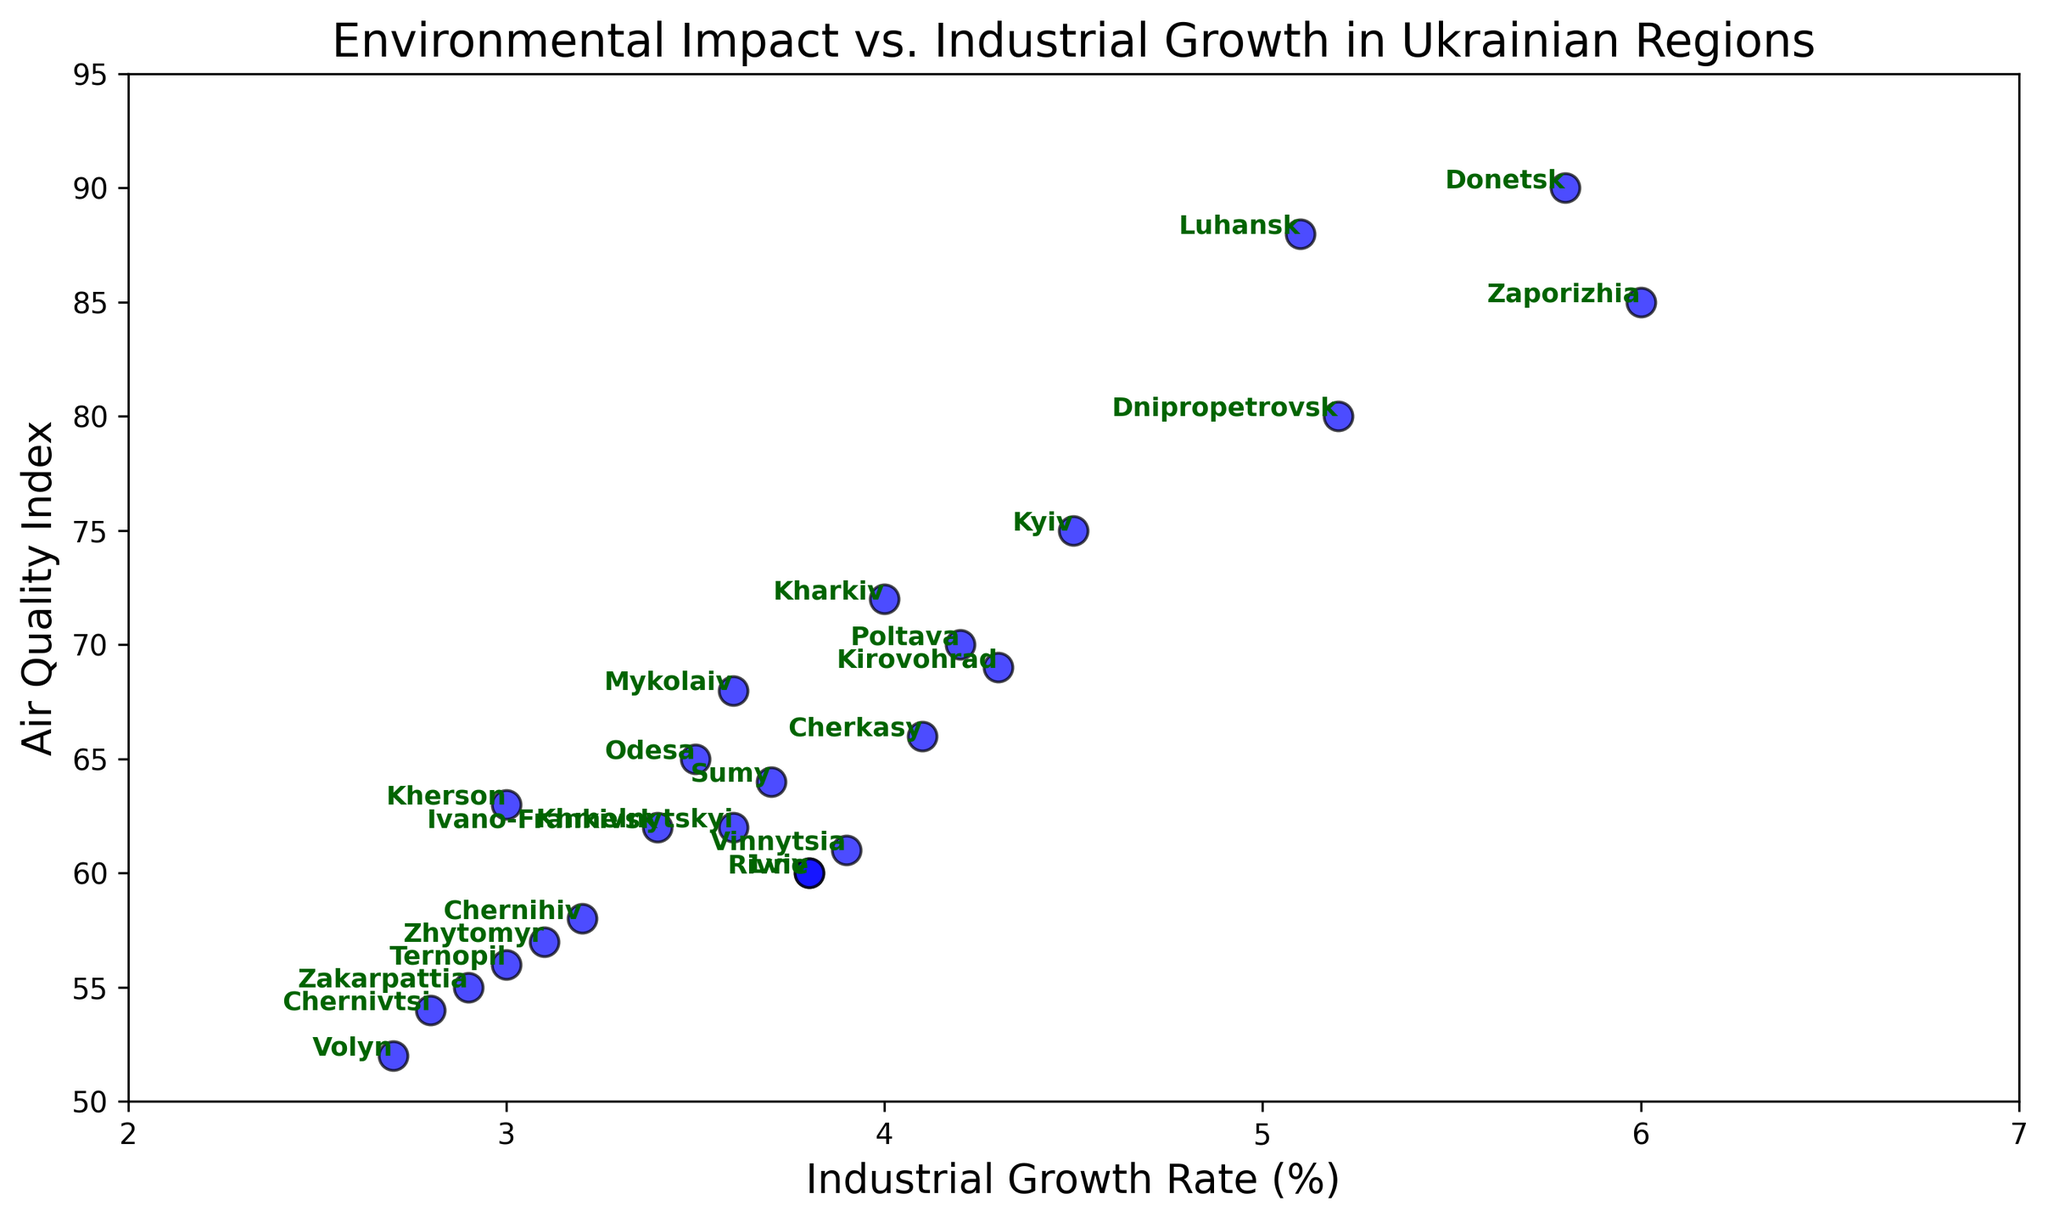Which region has the highest industrial growth rate? By observing the scatter plot, locate the point on the x-axis representing the highest value of 'Industrial Growth Rate'. Check the annotation to find the corresponding region.
Answer: Zaporizhia What is the air quality index for Lviv? Locate the point labeled 'Lviv' on the scatter plot, then read the corresponding value on the y-axis, which represents the 'Air Quality Index'.
Answer: 60 Which regions have a higher air quality index than Kharkiv? First, identify the air quality index value for Kharkiv, which is 72. Look for all other regions on the scatter plot with air quality index values greater than 72 by checking the y-axis.
Answer: Dnipropetrovsk, Zaporizhia, Donetsk, Luhansk Is there a region with a higher industrial growth rate than Kyiv but lower air quality? Locate Kyiv's point on the scatter plot, then identify regions with a higher 'Industrial Growth Rate' (greater than 4.5%) and compare their 'Air Quality Index' values to see if they are lower than 75.
Answer: Dnipropetrovsk, Zaporizhia, Donetsk, Luhansk What is the average industrial growth rate for regions with an air quality index below 60? First, identify regions where the 'Air Quality Index' is below 60, which are Chernivtsi, Zakarpattia, Ternopil, Volyn, Zhytomyr, Chernihiv, and Rivne. Sum their 'Industrial Growth Rate' values (2.8 + 2.9 + 3.0 + 2.7 + 3.1 + 3.2 + 3.8 = 21.5). There are 7 regions, so divide the sum by 7.
Answer: 3.07 Which region has the closest industrial growth rate to Khmelnytskyi but a better air quality index? Locate Khmelnytskyi on the scatter plot, noting its 'Industrial Growth Rate' (3.6) and 'Air Quality Index' (62). Find regions with 'Industrial Growth Rate' values close to 3.6 and compare their 'Air Quality Index' values to identify those with better air quality.
Answer: Mykolaiv (3.6, 68) and Sumy (3.7, 64) What is the relationship between industrial growth rate and air quality index in Ukrainian regions? Analyzing the scatter plot, observe the general trend or pattern formed by the data points. There appears to be a pattern suggesting that higher industrial growth rates are associated with worse air quality (higher values on the 'Air Quality Index').
Answer: Negative correlation Is there a pair of regions with the same air quality index but different industrial growth rates? Scan the scatter plot for regions sharing the same y-axis value (representing 'Air Quality Index') but different x-axis values (representing 'Industrial Growth Rate').
Answer: Lviv and Rivne both have an air quality index of 60 Which region has the lowest industrial growth rate and what is its air quality index? Locate the point on the x-axis representing the lowest value of 'Industrial Growth Rate' and find the corresponding annotation for the region. Then check its y-axis value.
Answer: Volyn, 52 